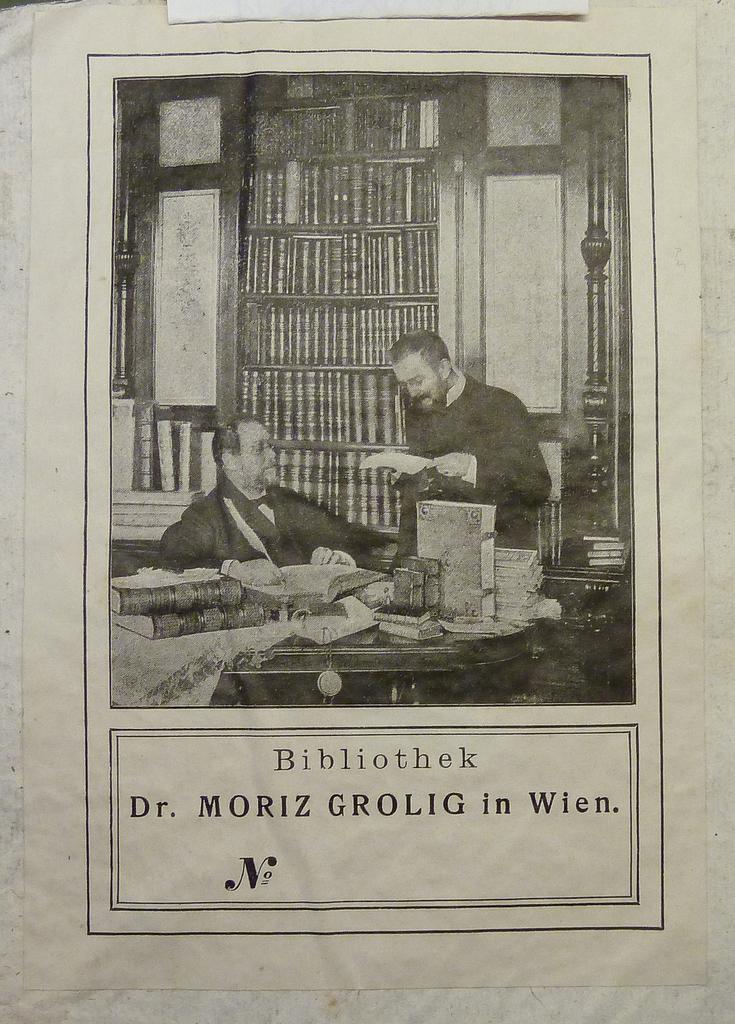Please provide a concise description of this image. In this image there is a black and white poster, in the poster there is a person sitting in the chair, beside him there is another person standing by holding a book, in front of them on the table there are books and some other objects, behind them there are books on the shelves, at the bottom of the poster there is some text written. 